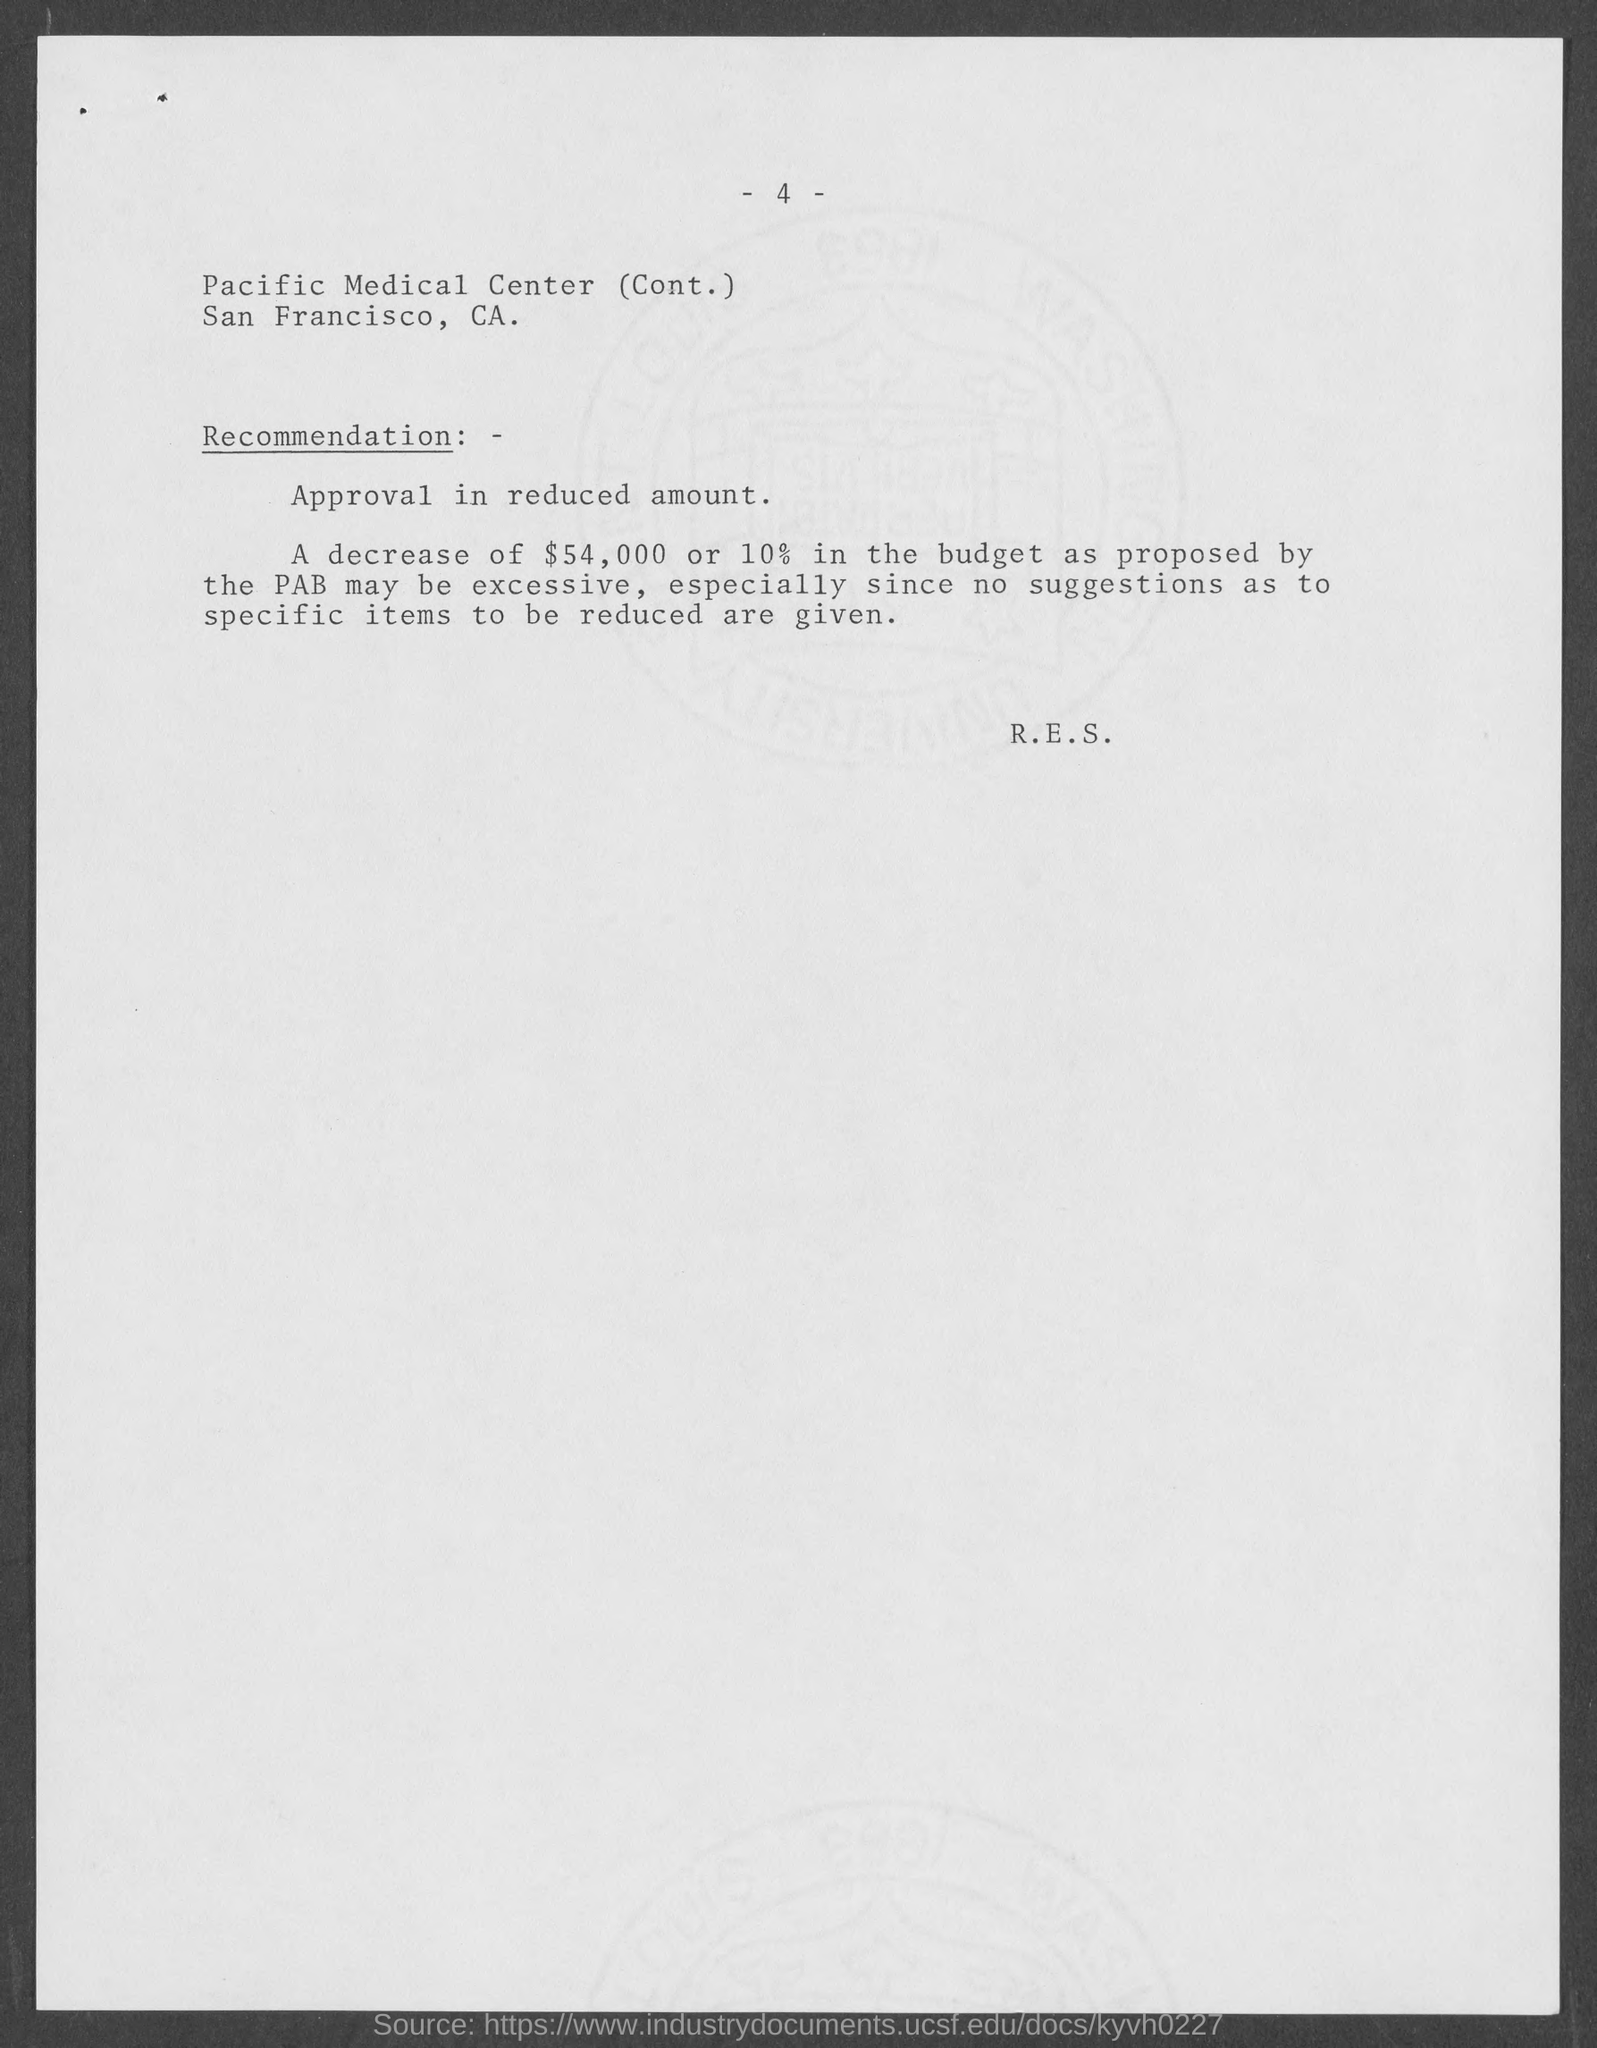Mention a couple of crucial points in this snapshot. The page number at the top of the page is 4. Pacific Medical Center is located in San Francisco County. 